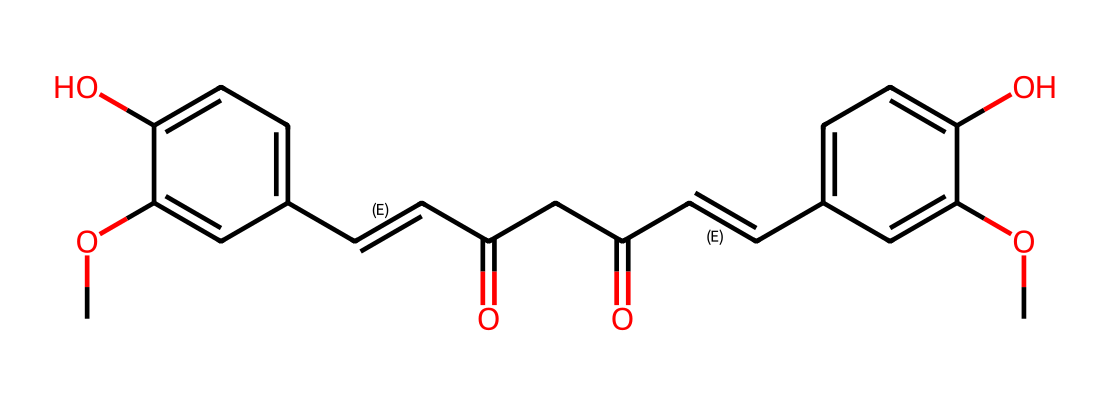What is the molecular formula of curcumin? By analyzing the SMILES representation, we can determine all the atoms present in the compound. The breakdown shows there are 21 carbon (C) atoms, 20 hydrogen (H) atoms, 6 oxygen (O) atoms. Thus, the molecular formula can be constructed as C21H20O6.
Answer: C21H20O6 How many aromatic rings are present in curcumin? The SMILES structure contains two distinct benzene-like rings, which can be identified by observing the aromatic portions of the molecule. Each ring has alternating double bonds. Therefore, there are two aromatic rings.
Answer: 2 What functional groups are present in curcumin? The structure includes hydroxyl groups (-OH) and carbonyl groups (C=O). Hydroxyl groups can be identified from the -O in the molecular structure, and the carbonyl groups come from the structures with C=O. Thus, the key functional groups present are phenolic and ketone groups.
Answer: phenolic and ketone groups What type of antioxidant is curcumin classified as? Curcumin acts primarily as a scavenging antioxidant due to its ability to donate hydrogen atoms and neutralize free radicals. This is inferred from its molecular structure showing several -OH groups which contribute to its antioxidant activity.
Answer: scavenging antioxidant Which part of curcumin contributes to its antioxidant properties? The phenolic hydroxyl groups in the structure are responsible for curcumin's antioxidant activity. These groups allow the compound to donate hydrogen atoms, enabling it to neutralize free radicals effectively.
Answer: phenolic hydroxyl groups 